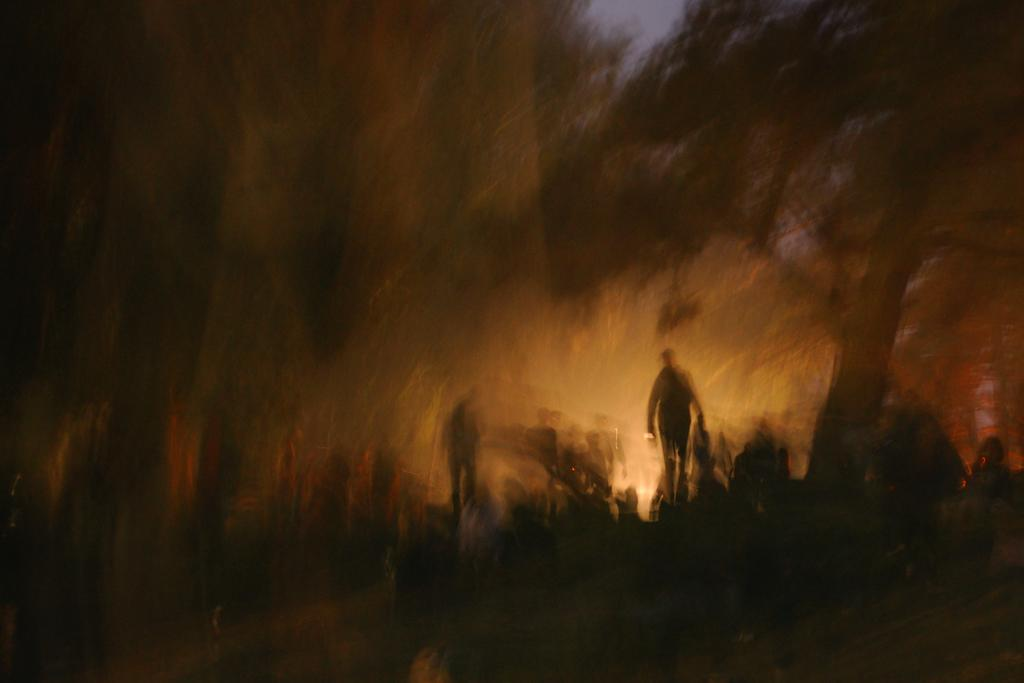Who or what can be seen in the image? There are persons in the image. What type of natural elements are present in the image? There are trees in the image. What is visible in the background of the image? The sky is visible in the image. What type of store can be seen in the image? There is no store present in the image. What is the purpose of the nail in the image? There is no nail present in the image. 